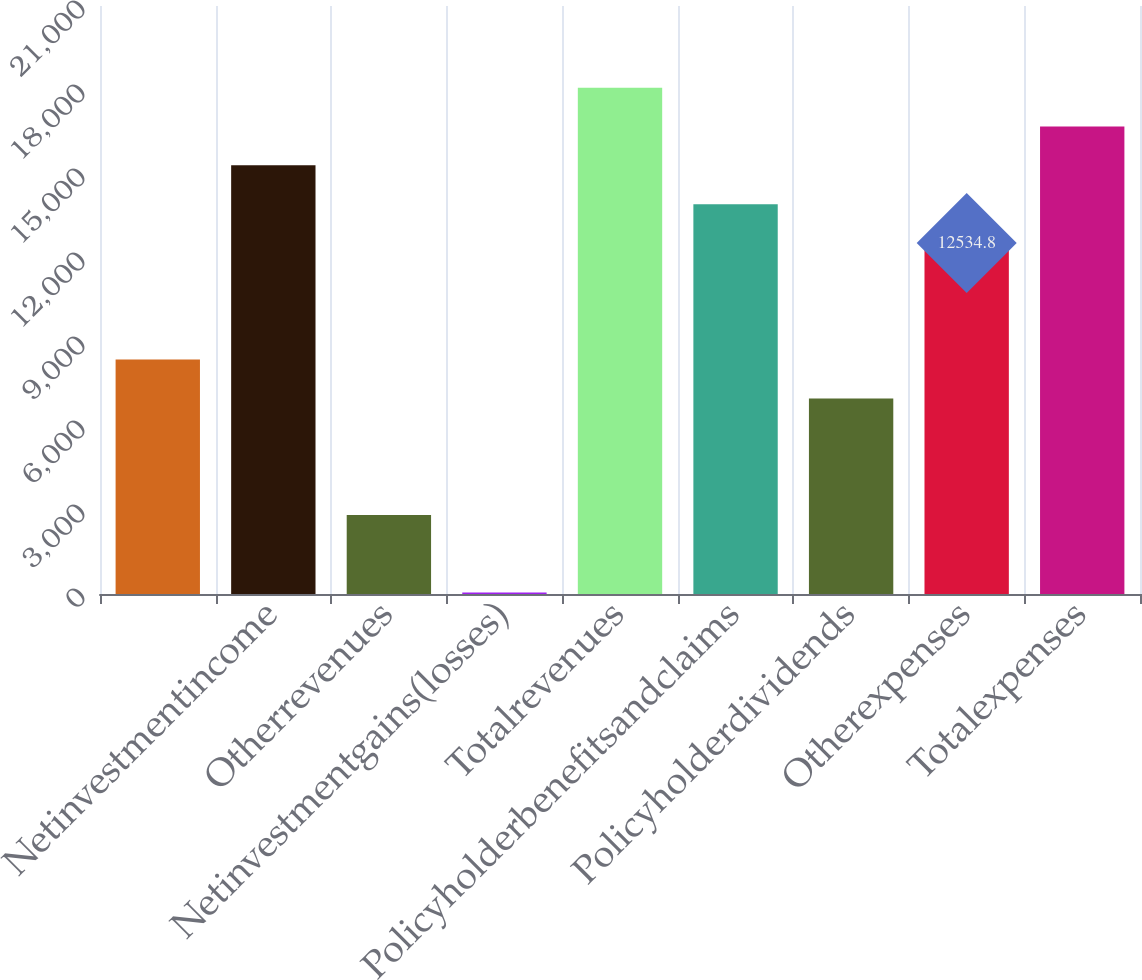<chart> <loc_0><loc_0><loc_500><loc_500><bar_chart><ecel><fcel>Netinvestmentincome<fcel>Otherrevenues<fcel>Netinvestmentgains(losses)<fcel>Totalrevenues<fcel>Policyholderbenefitsandclaims<fcel>Policyholderdividends<fcel>Otherexpenses<fcel>Totalexpenses<nl><fcel>8373.2<fcel>15309.2<fcel>2824.4<fcel>50<fcel>18083.6<fcel>13922<fcel>6986<fcel>12534.8<fcel>16696.4<nl></chart> 